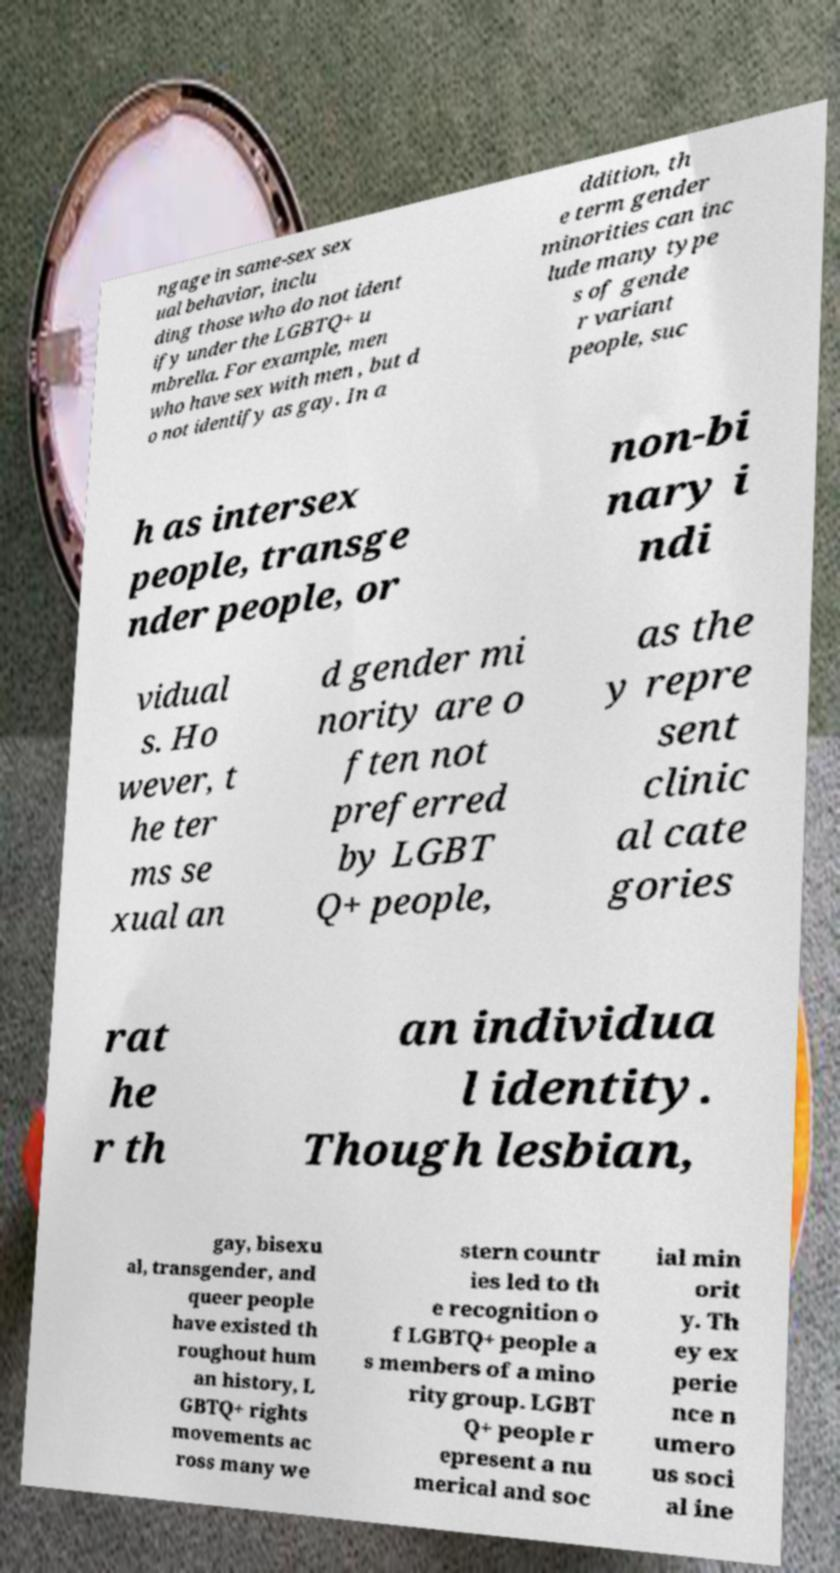I need the written content from this picture converted into text. Can you do that? ngage in same-sex sex ual behavior, inclu ding those who do not ident ify under the LGBTQ+ u mbrella. For example, men who have sex with men , but d o not identify as gay. In a ddition, th e term gender minorities can inc lude many type s of gende r variant people, suc h as intersex people, transge nder people, or non-bi nary i ndi vidual s. Ho wever, t he ter ms se xual an d gender mi nority are o ften not preferred by LGBT Q+ people, as the y repre sent clinic al cate gories rat he r th an individua l identity. Though lesbian, gay, bisexu al, transgender, and queer people have existed th roughout hum an history, L GBTQ+ rights movements ac ross many we stern countr ies led to th e recognition o f LGBTQ+ people a s members of a mino rity group. LGBT Q+ people r epresent a nu merical and soc ial min orit y. Th ey ex perie nce n umero us soci al ine 